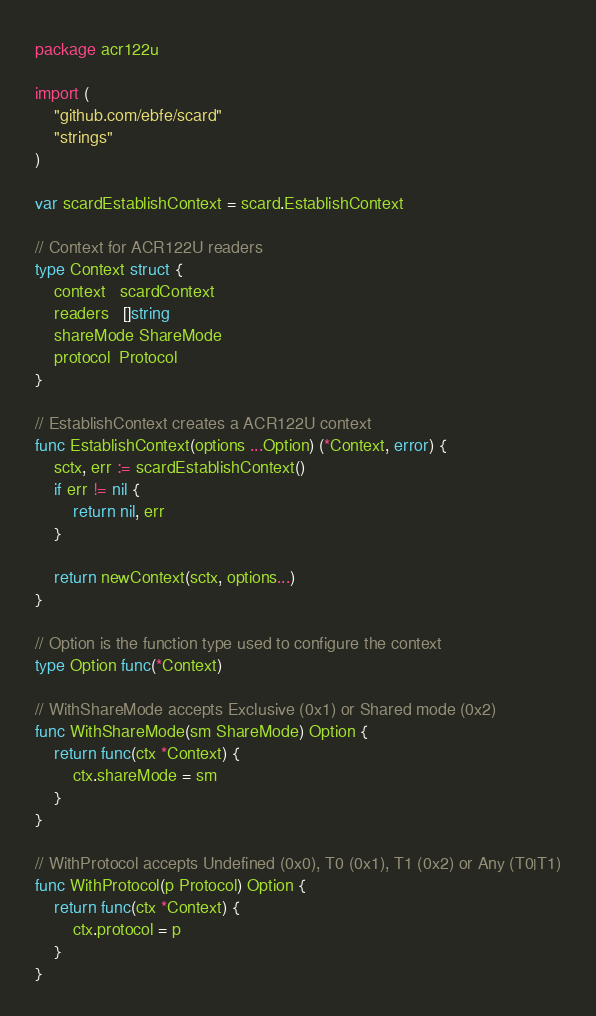Convert code to text. <code><loc_0><loc_0><loc_500><loc_500><_Go_>package acr122u

import (
	"github.com/ebfe/scard"
	"strings"
)

var scardEstablishContext = scard.EstablishContext

// Context for ACR122U readers
type Context struct {
	context   scardContext
	readers   []string
	shareMode ShareMode
	protocol  Protocol
}

// EstablishContext creates a ACR122U context
func EstablishContext(options ...Option) (*Context, error) {
	sctx, err := scardEstablishContext()
	if err != nil {
		return nil, err
	}

	return newContext(sctx, options...)
}

// Option is the function type used to configure the context
type Option func(*Context)

// WithShareMode accepts Exclusive (0x1) or Shared mode (0x2)
func WithShareMode(sm ShareMode) Option {
	return func(ctx *Context) {
		ctx.shareMode = sm
	}
}

// WithProtocol accepts Undefined (0x0), T0 (0x1), T1 (0x2) or Any (T0|T1)
func WithProtocol(p Protocol) Option {
	return func(ctx *Context) {
		ctx.protocol = p
	}
}
</code> 